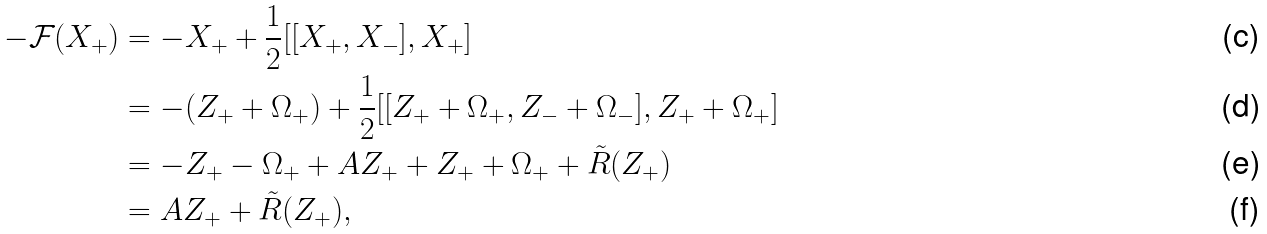<formula> <loc_0><loc_0><loc_500><loc_500>- \mathcal { F } ( X _ { + } ) & = - X _ { + } + \frac { 1 } { 2 } [ [ X _ { + } , X _ { - } ] , X _ { + } ] \\ & = - ( Z _ { + } + \Omega _ { + } ) + \frac { 1 } { 2 } [ [ Z _ { + } + \Omega _ { + } , Z _ { - } + \Omega _ { - } ] , Z _ { + } + \Omega _ { + } ] \\ & = - Z _ { + } - \Omega _ { + } + A Z _ { + } + Z _ { + } + \Omega _ { + } + \tilde { R } ( Z _ { + } ) \\ & = A Z _ { + } + \tilde { R } ( Z _ { + } ) ,</formula> 